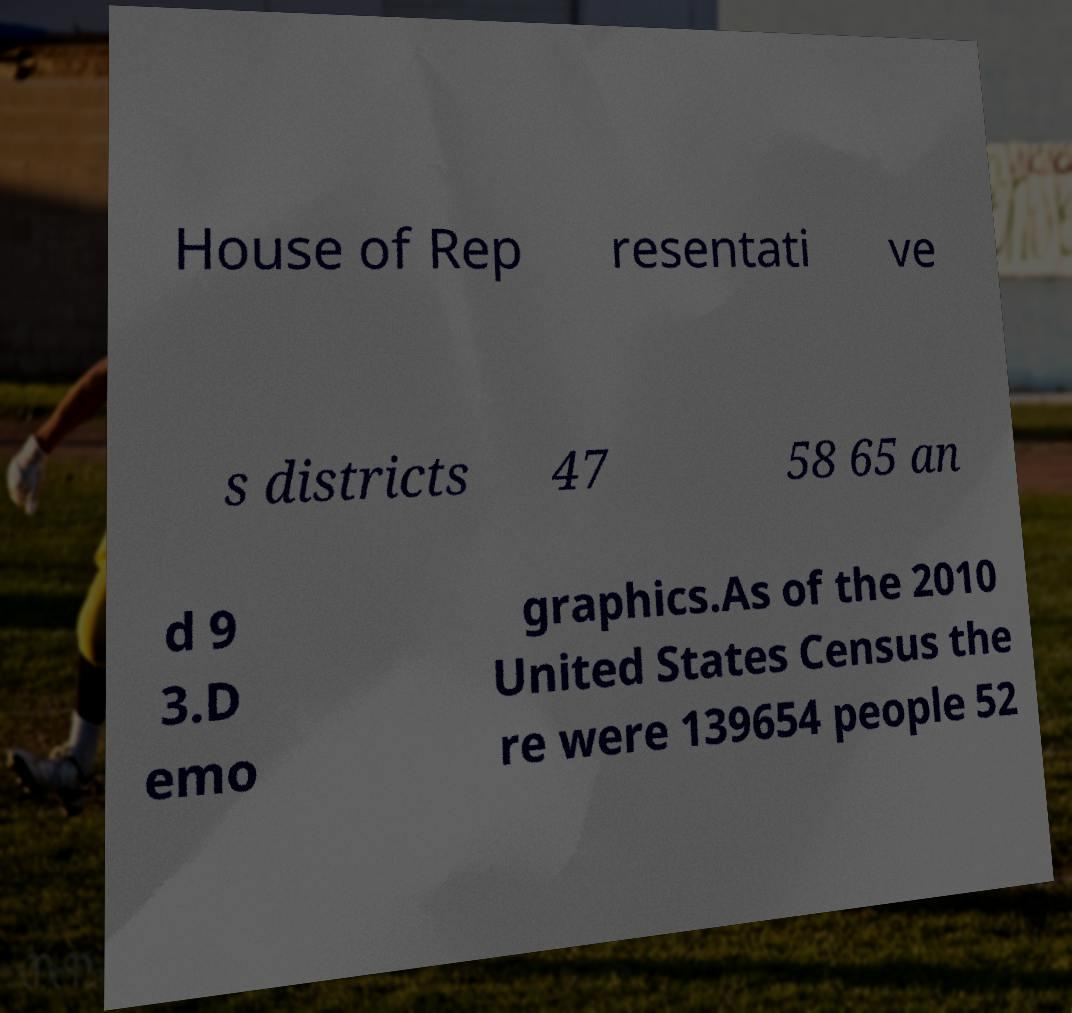Please read and relay the text visible in this image. What does it say? House of Rep resentati ve s districts 47 58 65 an d 9 3.D emo graphics.As of the 2010 United States Census the re were 139654 people 52 